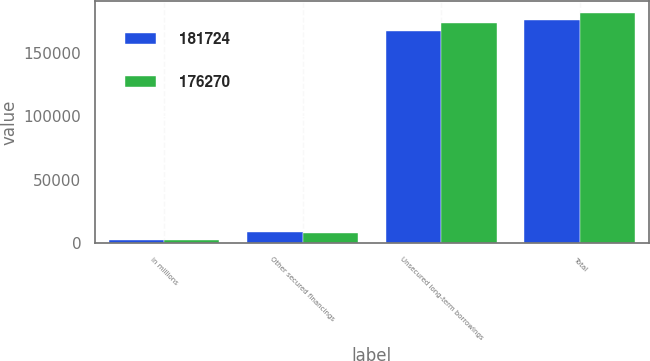<chart> <loc_0><loc_0><loc_500><loc_500><stacked_bar_chart><ecel><fcel>in millions<fcel>Other secured financings<fcel>Unsecured long-term borrowings<fcel>Total<nl><fcel>181724<fcel>2012<fcel>8965<fcel>167305<fcel>176270<nl><fcel>176270<fcel>2011<fcel>8179<fcel>173545<fcel>181724<nl></chart> 